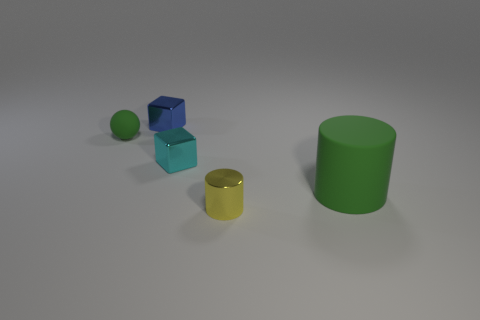The green ball has what size?
Your answer should be very brief. Small. What shape is the large rubber thing that is the same color as the small matte object?
Offer a terse response. Cylinder. Is the number of big cylinders in front of the yellow object less than the number of rubber objects to the left of the large cylinder?
Provide a short and direct response. Yes. The green thing that is behind the object that is to the right of the yellow shiny object is what shape?
Offer a very short reply. Sphere. What number of other things are the same material as the green ball?
Your answer should be compact. 1. Is there anything else that has the same size as the rubber cylinder?
Your response must be concise. No. Is the number of blue cubes greater than the number of brown metal cubes?
Offer a terse response. Yes. What size is the metallic object behind the sphere that is behind the small object in front of the rubber cylinder?
Your response must be concise. Small. There is a rubber ball; is it the same size as the green matte thing that is on the right side of the cyan object?
Give a very brief answer. No. Is the number of small green matte balls on the right side of the tiny cyan object less than the number of green shiny spheres?
Provide a short and direct response. No. 